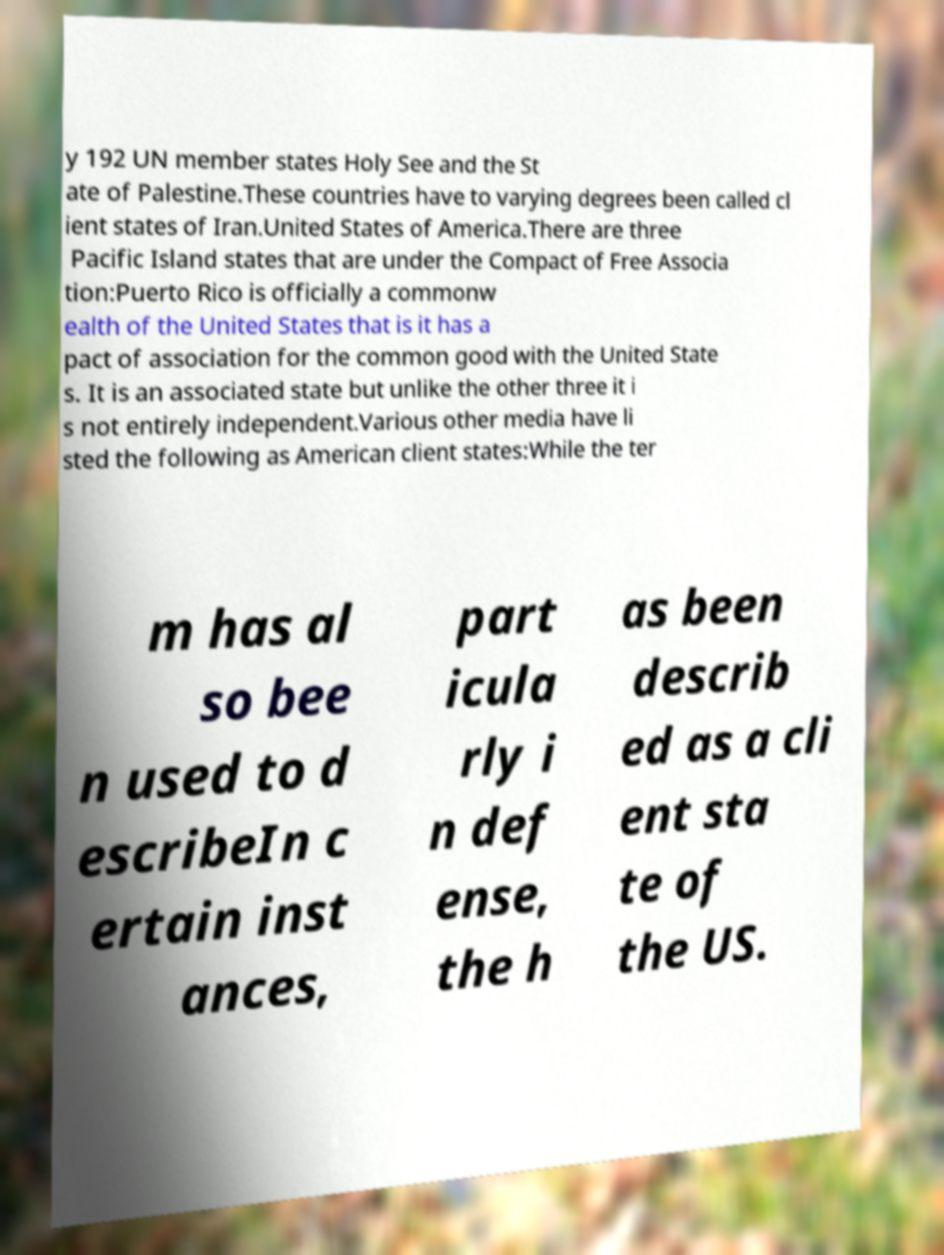Can you read and provide the text displayed in the image?This photo seems to have some interesting text. Can you extract and type it out for me? y 192 UN member states Holy See and the St ate of Palestine.These countries have to varying degrees been called cl ient states of Iran.United States of America.There are three Pacific Island states that are under the Compact of Free Associa tion:Puerto Rico is officially a commonw ealth of the United States that is it has a pact of association for the common good with the United State s. It is an associated state but unlike the other three it i s not entirely independent.Various other media have li sted the following as American client states:While the ter m has al so bee n used to d escribeIn c ertain inst ances, part icula rly i n def ense, the h as been describ ed as a cli ent sta te of the US. 